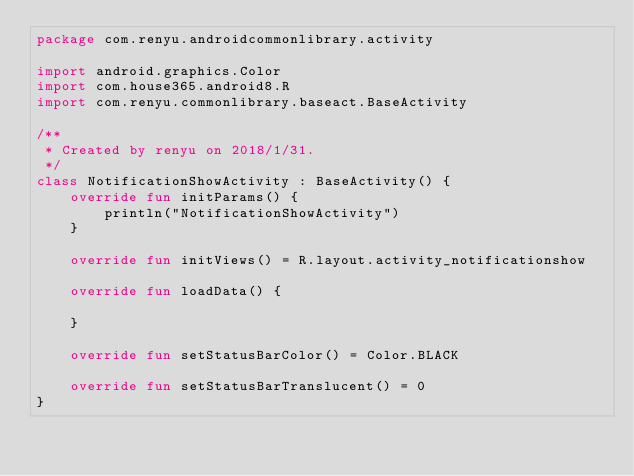Convert code to text. <code><loc_0><loc_0><loc_500><loc_500><_Kotlin_>package com.renyu.androidcommonlibrary.activity

import android.graphics.Color
import com.house365.android8.R
import com.renyu.commonlibrary.baseact.BaseActivity

/**
 * Created by renyu on 2018/1/31.
 */
class NotificationShowActivity : BaseActivity() {
    override fun initParams() {
        println("NotificationShowActivity")
    }

    override fun initViews() = R.layout.activity_notificationshow

    override fun loadData() {

    }

    override fun setStatusBarColor() = Color.BLACK

    override fun setStatusBarTranslucent() = 0
}</code> 